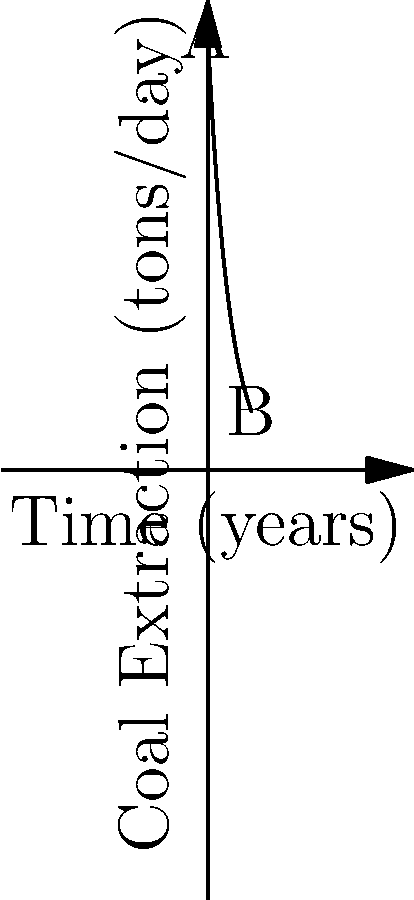The graph shows the rate of coal extraction in tons per day over a 10-year period. If the rate of extraction at time $t$ is given by the function $f(t) = 100e^{-0.2t}$, what is the instantaneous rate of change of coal extraction after 5 years? To find the instantaneous rate of change after 5 years, we need to calculate the derivative of the given function and evaluate it at t = 5.

Step 1: Find the derivative of $f(t) = 100e^{-0.2t}$
Using the chain rule, we get:
$f'(t) = 100 \cdot (-0.2) \cdot e^{-0.2t} = -20e^{-0.2t}$

Step 2: Evaluate $f'(t)$ at t = 5
$f'(5) = -20e^{-0.2(5)} = -20e^{-1} \approx -7.36$

Step 3: Interpret the result
The negative value indicates that the rate of coal extraction is decreasing. After 5 years, the rate of extraction is decreasing by approximately 7.36 tons per day per year.
Answer: $-7.36$ tons/day/year 